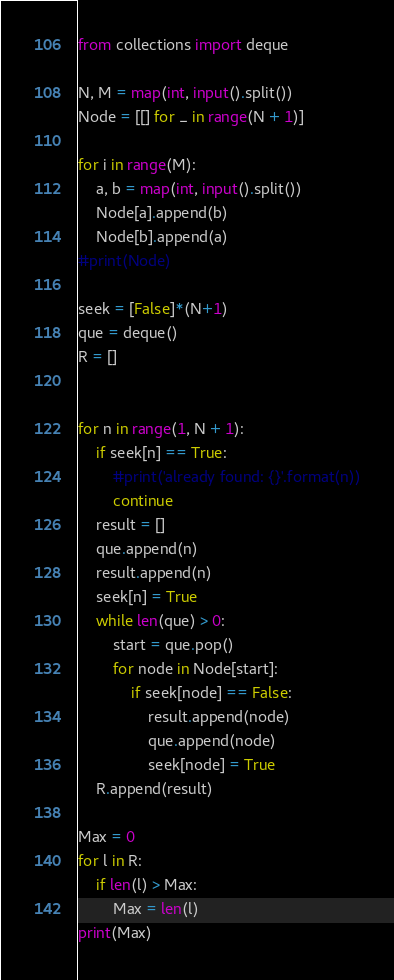Convert code to text. <code><loc_0><loc_0><loc_500><loc_500><_Python_>from collections import deque

N, M = map(int, input().split())
Node = [[] for _ in range(N + 1)]

for i in range(M):
    a, b = map(int, input().split())
    Node[a].append(b)
    Node[b].append(a)
#print(Node)

seek = [False]*(N+1)
que = deque()
R = []


for n in range(1, N + 1):
    if seek[n] == True:
        #print('already found: {}'.format(n))
        continue
    result = []
    que.append(n)
    result.append(n)
    seek[n] = True
    while len(que) > 0:
        start = que.pop()
        for node in Node[start]:
            if seek[node] == False:
                result.append(node)
                que.append(node)
                seek[node] = True
    R.append(result)

Max = 0
for l in R:
    if len(l) > Max:
        Max = len(l)
print(Max)</code> 